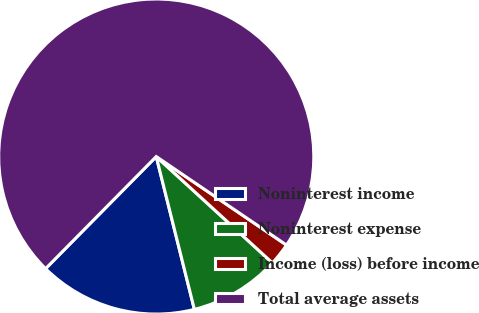Convert chart to OTSL. <chart><loc_0><loc_0><loc_500><loc_500><pie_chart><fcel>Noninterest income<fcel>Noninterest expense<fcel>Income (loss) before income<fcel>Total average assets<nl><fcel>16.29%<fcel>9.31%<fcel>2.3%<fcel>72.11%<nl></chart> 